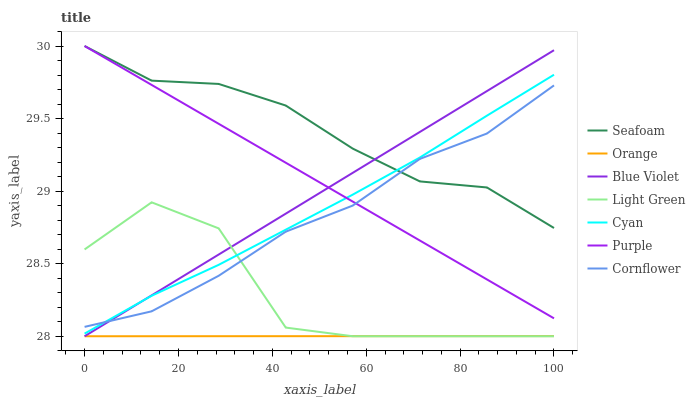Does Purple have the minimum area under the curve?
Answer yes or no. No. Does Purple have the maximum area under the curve?
Answer yes or no. No. Is Purple the smoothest?
Answer yes or no. No. Is Purple the roughest?
Answer yes or no. No. Does Purple have the lowest value?
Answer yes or no. No. Does Light Green have the highest value?
Answer yes or no. No. Is Light Green less than Seafoam?
Answer yes or no. Yes. Is Cornflower greater than Orange?
Answer yes or no. Yes. Does Light Green intersect Seafoam?
Answer yes or no. No. 